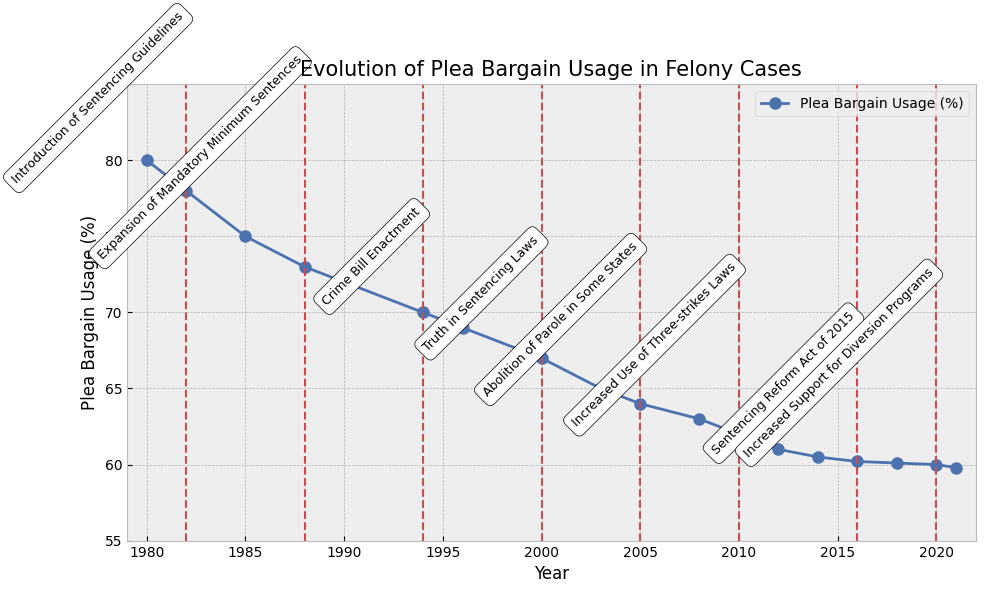What is the overall trend in the use of plea bargains from 1980 to 2021? The figure shows a decreasing trend in the usage of plea bargains over time, starting from 80% in 1980 and dropping to 59.8% in 2021.
Answer: A decreasing trend How did the plea bargain usage change after the introduction of Sentencing Guidelines in 1982? In 1982, the plea bargain usage was 78%. By 1985, it had decreased to 75%. This indicates a slight drop following the introduction of Sentencing Guidelines.
Answer: It decreased What is the difference in plea bargain usage between the years 1980 and 2021? In 1980, the plea bargain usage was 80%, and in 2021, it was 59.8%. The difference is 80% - 59.8% = 20.2%.
Answer: 20.2% Which policy shift corresponds to the largest visible decrease in plea bargain usage? The largest visible decrease in the figure appears between 1982 (78%) and 1985 (75%), corresponding to the introduction of Sentencing Guidelines.
Answer: Introduction of Sentencing Guidelines What is the average plea bargain usage from 1980 to 2021? Sum all the plea bargain percentages from 1980 to 2021 and divide by the number of years: (80 + 78 + 75 + 73 + 72 + 70 + 69 + 67 + 65 + 64 + 63 + 62 + 61 + 60.5 + 60.2 + 60.1 + 60 + 59.8) / 18. The total sum is 1229.6, so the average is 1229.6 / 18 ≈ 68.3.
Answer: 68.3 How many times did the plea bargain usage percentage remain unchanged between consecutive years? By closely examining the values between consecutive years, we can see that the percentage remained unchanged only between 2018 (60.1%) and 2020 (60%).
Answer: Once Did the plea bargain usage ever increase between any two consecutive years in the given time period? No, the figure shows a consistent decreasing trend in plea bargain usage; there are no increases between any consecutive years.
Answer: No Compare the plea bargain usage percentages in 1988 and 2020. Which year had the higher usage? In 1988, the plea bargain usage was 73%. In 2020, it was 60%. Therefore, 1988 had the higher usage.
Answer: 1988 What was the plea bargain usage percentage in the year the Truth in Sentencing Laws were enacted? The Truth in Sentencing Laws were enacted in 2000, and the plea bargain usage percentage in that year was 67%.
Answer: 67% 